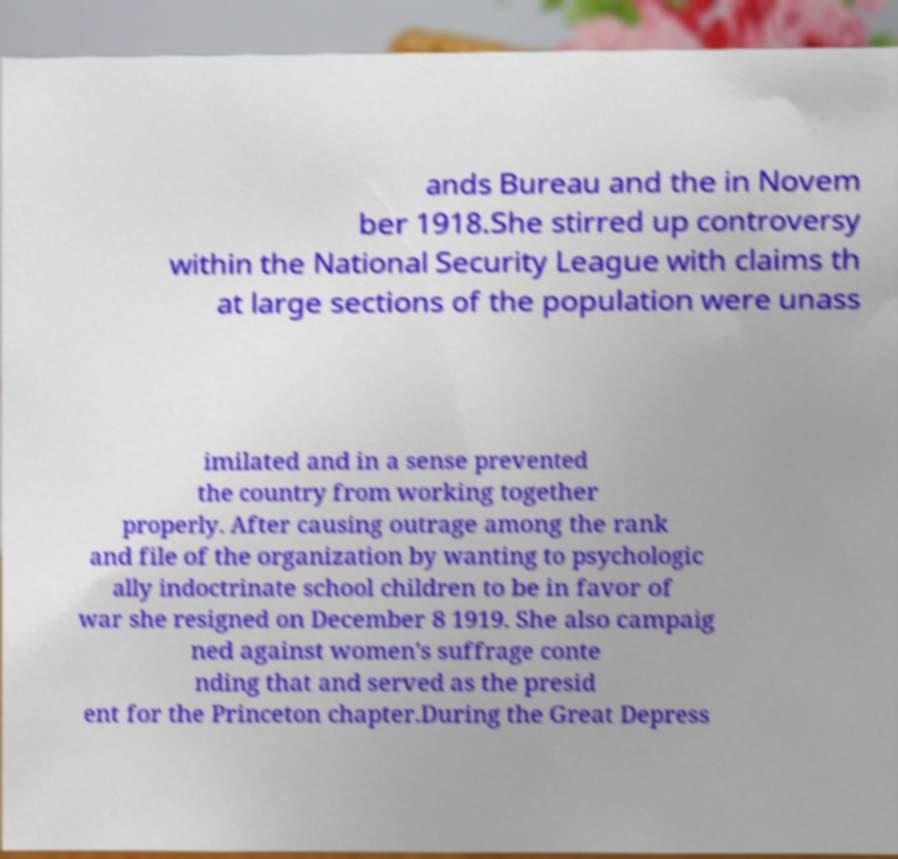Please identify and transcribe the text found in this image. ands Bureau and the in Novem ber 1918.She stirred up controversy within the National Security League with claims th at large sections of the population were unass imilated and in a sense prevented the country from working together properly. After causing outrage among the rank and file of the organization by wanting to psychologic ally indoctrinate school children to be in favor of war she resigned on December 8 1919. She also campaig ned against women's suffrage conte nding that and served as the presid ent for the Princeton chapter.During the Great Depress 